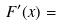<formula> <loc_0><loc_0><loc_500><loc_500>F ^ { \prime } ( x ) =</formula> 